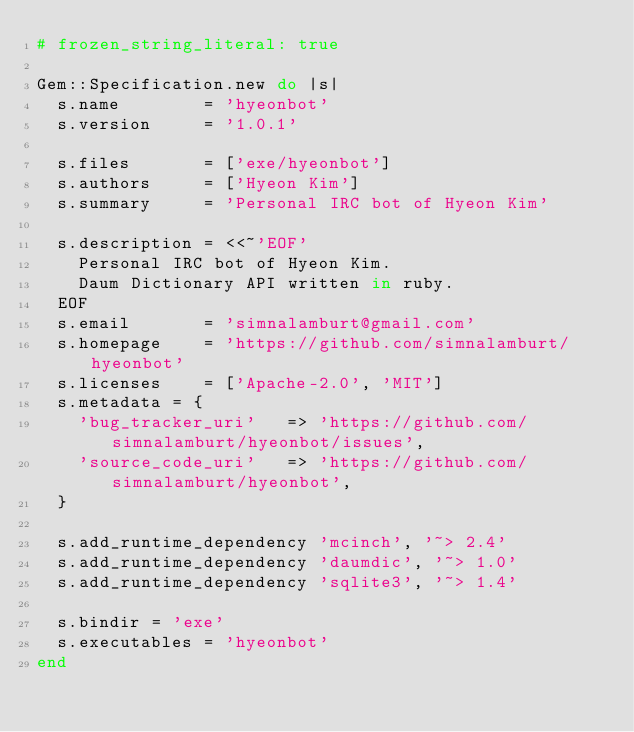Convert code to text. <code><loc_0><loc_0><loc_500><loc_500><_Ruby_># frozen_string_literal: true

Gem::Specification.new do |s|
  s.name        = 'hyeonbot'
  s.version     = '1.0.1'

  s.files       = ['exe/hyeonbot']
  s.authors     = ['Hyeon Kim']
  s.summary     = 'Personal IRC bot of Hyeon Kim'

  s.description = <<~'EOF'
    Personal IRC bot of Hyeon Kim.
    Daum Dictionary API written in ruby.
  EOF
  s.email       = 'simnalamburt@gmail.com'
  s.homepage    = 'https://github.com/simnalamburt/hyeonbot'
  s.licenses    = ['Apache-2.0', 'MIT']
  s.metadata = {
    'bug_tracker_uri'   => 'https://github.com/simnalamburt/hyeonbot/issues',
    'source_code_uri'   => 'https://github.com/simnalamburt/hyeonbot',
  }

  s.add_runtime_dependency 'mcinch', '~> 2.4'
  s.add_runtime_dependency 'daumdic', '~> 1.0'
  s.add_runtime_dependency 'sqlite3', '~> 1.4'

  s.bindir = 'exe'
  s.executables = 'hyeonbot'
end
</code> 